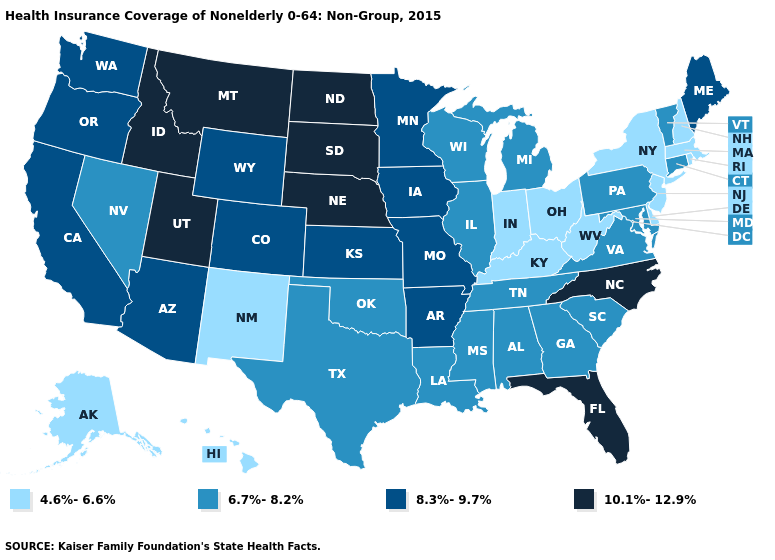What is the lowest value in the West?
Write a very short answer. 4.6%-6.6%. What is the value of Connecticut?
Write a very short answer. 6.7%-8.2%. What is the value of Oklahoma?
Short answer required. 6.7%-8.2%. What is the value of Wyoming?
Be succinct. 8.3%-9.7%. What is the value of Mississippi?
Write a very short answer. 6.7%-8.2%. What is the value of Iowa?
Concise answer only. 8.3%-9.7%. Which states hav the highest value in the Northeast?
Concise answer only. Maine. Does the first symbol in the legend represent the smallest category?
Short answer required. Yes. Name the states that have a value in the range 4.6%-6.6%?
Keep it brief. Alaska, Delaware, Hawaii, Indiana, Kentucky, Massachusetts, New Hampshire, New Jersey, New Mexico, New York, Ohio, Rhode Island, West Virginia. Name the states that have a value in the range 4.6%-6.6%?
Short answer required. Alaska, Delaware, Hawaii, Indiana, Kentucky, Massachusetts, New Hampshire, New Jersey, New Mexico, New York, Ohio, Rhode Island, West Virginia. Which states have the highest value in the USA?
Give a very brief answer. Florida, Idaho, Montana, Nebraska, North Carolina, North Dakota, South Dakota, Utah. Which states have the lowest value in the USA?
Keep it brief. Alaska, Delaware, Hawaii, Indiana, Kentucky, Massachusetts, New Hampshire, New Jersey, New Mexico, New York, Ohio, Rhode Island, West Virginia. Among the states that border Connecticut , which have the lowest value?
Answer briefly. Massachusetts, New York, Rhode Island. Which states have the lowest value in the South?
Concise answer only. Delaware, Kentucky, West Virginia. Name the states that have a value in the range 4.6%-6.6%?
Give a very brief answer. Alaska, Delaware, Hawaii, Indiana, Kentucky, Massachusetts, New Hampshire, New Jersey, New Mexico, New York, Ohio, Rhode Island, West Virginia. 